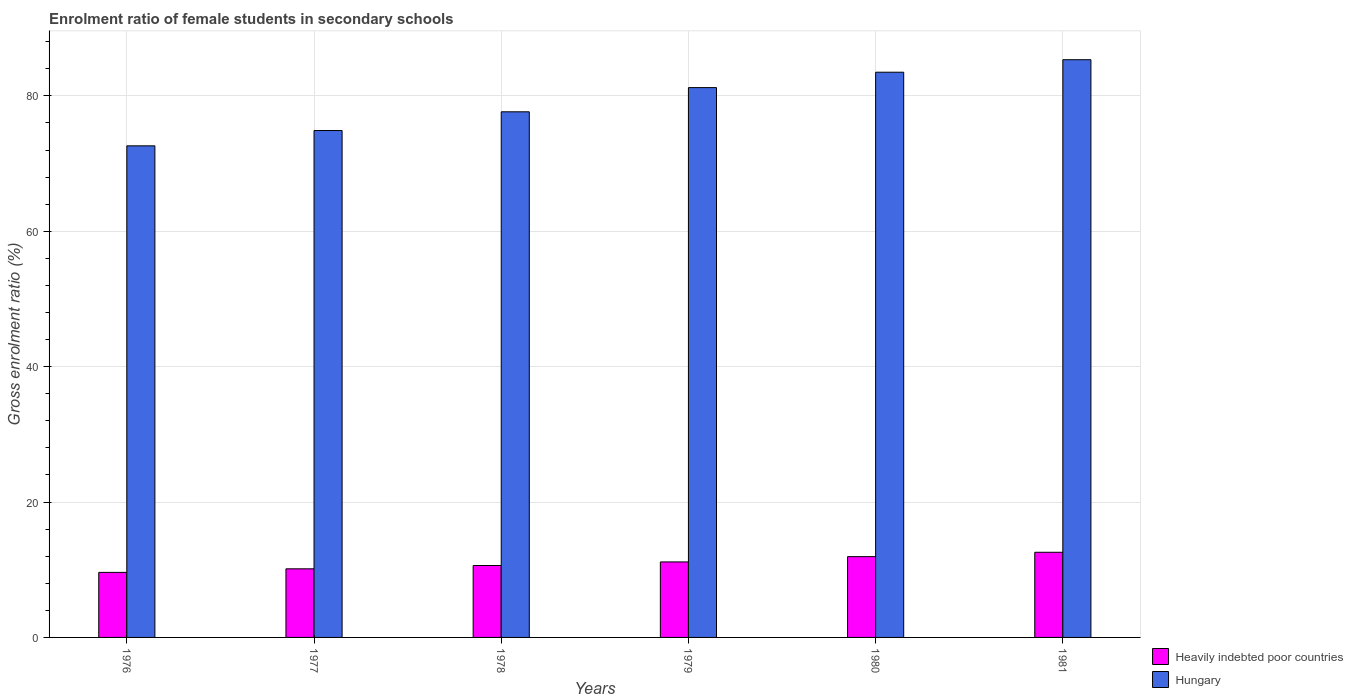How many groups of bars are there?
Provide a succinct answer. 6. Are the number of bars per tick equal to the number of legend labels?
Provide a succinct answer. Yes. How many bars are there on the 4th tick from the left?
Give a very brief answer. 2. What is the label of the 2nd group of bars from the left?
Your answer should be very brief. 1977. In how many cases, is the number of bars for a given year not equal to the number of legend labels?
Your answer should be compact. 0. What is the enrolment ratio of female students in secondary schools in Hungary in 1980?
Your answer should be very brief. 83.49. Across all years, what is the maximum enrolment ratio of female students in secondary schools in Heavily indebted poor countries?
Your answer should be compact. 12.58. Across all years, what is the minimum enrolment ratio of female students in secondary schools in Hungary?
Provide a short and direct response. 72.61. In which year was the enrolment ratio of female students in secondary schools in Hungary minimum?
Provide a succinct answer. 1976. What is the total enrolment ratio of female students in secondary schools in Hungary in the graph?
Your answer should be very brief. 475.18. What is the difference between the enrolment ratio of female students in secondary schools in Heavily indebted poor countries in 1976 and that in 1977?
Your answer should be very brief. -0.53. What is the difference between the enrolment ratio of female students in secondary schools in Hungary in 1981 and the enrolment ratio of female students in secondary schools in Heavily indebted poor countries in 1978?
Provide a short and direct response. 74.71. What is the average enrolment ratio of female students in secondary schools in Hungary per year?
Offer a very short reply. 79.2. In the year 1979, what is the difference between the enrolment ratio of female students in secondary schools in Hungary and enrolment ratio of female students in secondary schools in Heavily indebted poor countries?
Your response must be concise. 70.06. What is the ratio of the enrolment ratio of female students in secondary schools in Hungary in 1979 to that in 1981?
Provide a succinct answer. 0.95. Is the enrolment ratio of female students in secondary schools in Heavily indebted poor countries in 1977 less than that in 1981?
Keep it short and to the point. Yes. Is the difference between the enrolment ratio of female students in secondary schools in Hungary in 1977 and 1980 greater than the difference between the enrolment ratio of female students in secondary schools in Heavily indebted poor countries in 1977 and 1980?
Give a very brief answer. No. What is the difference between the highest and the second highest enrolment ratio of female students in secondary schools in Heavily indebted poor countries?
Offer a very short reply. 0.64. What is the difference between the highest and the lowest enrolment ratio of female students in secondary schools in Heavily indebted poor countries?
Ensure brevity in your answer.  2.97. Is the sum of the enrolment ratio of female students in secondary schools in Hungary in 1980 and 1981 greater than the maximum enrolment ratio of female students in secondary schools in Heavily indebted poor countries across all years?
Provide a succinct answer. Yes. What does the 1st bar from the left in 1981 represents?
Give a very brief answer. Heavily indebted poor countries. What does the 2nd bar from the right in 1979 represents?
Your response must be concise. Heavily indebted poor countries. Does the graph contain grids?
Make the answer very short. Yes. Where does the legend appear in the graph?
Your answer should be compact. Bottom right. How many legend labels are there?
Ensure brevity in your answer.  2. What is the title of the graph?
Give a very brief answer. Enrolment ratio of female students in secondary schools. Does "Middle East & North Africa (all income levels)" appear as one of the legend labels in the graph?
Provide a short and direct response. No. What is the label or title of the Y-axis?
Your answer should be very brief. Gross enrolment ratio (%). What is the Gross enrolment ratio (%) of Heavily indebted poor countries in 1976?
Your response must be concise. 9.61. What is the Gross enrolment ratio (%) in Hungary in 1976?
Provide a succinct answer. 72.61. What is the Gross enrolment ratio (%) of Heavily indebted poor countries in 1977?
Offer a very short reply. 10.13. What is the Gross enrolment ratio (%) of Hungary in 1977?
Provide a short and direct response. 74.88. What is the Gross enrolment ratio (%) of Heavily indebted poor countries in 1978?
Ensure brevity in your answer.  10.62. What is the Gross enrolment ratio (%) in Hungary in 1978?
Provide a short and direct response. 77.64. What is the Gross enrolment ratio (%) in Heavily indebted poor countries in 1979?
Your response must be concise. 11.15. What is the Gross enrolment ratio (%) in Hungary in 1979?
Offer a terse response. 81.22. What is the Gross enrolment ratio (%) in Heavily indebted poor countries in 1980?
Offer a very short reply. 11.93. What is the Gross enrolment ratio (%) in Hungary in 1980?
Your answer should be compact. 83.49. What is the Gross enrolment ratio (%) of Heavily indebted poor countries in 1981?
Provide a succinct answer. 12.58. What is the Gross enrolment ratio (%) in Hungary in 1981?
Provide a succinct answer. 85.34. Across all years, what is the maximum Gross enrolment ratio (%) of Heavily indebted poor countries?
Offer a terse response. 12.58. Across all years, what is the maximum Gross enrolment ratio (%) in Hungary?
Offer a terse response. 85.34. Across all years, what is the minimum Gross enrolment ratio (%) in Heavily indebted poor countries?
Your answer should be very brief. 9.61. Across all years, what is the minimum Gross enrolment ratio (%) of Hungary?
Make the answer very short. 72.61. What is the total Gross enrolment ratio (%) in Heavily indebted poor countries in the graph?
Offer a very short reply. 66.03. What is the total Gross enrolment ratio (%) of Hungary in the graph?
Your response must be concise. 475.18. What is the difference between the Gross enrolment ratio (%) of Heavily indebted poor countries in 1976 and that in 1977?
Provide a short and direct response. -0.53. What is the difference between the Gross enrolment ratio (%) of Hungary in 1976 and that in 1977?
Offer a very short reply. -2.26. What is the difference between the Gross enrolment ratio (%) in Heavily indebted poor countries in 1976 and that in 1978?
Offer a terse response. -1.01. What is the difference between the Gross enrolment ratio (%) of Hungary in 1976 and that in 1978?
Your answer should be very brief. -5.03. What is the difference between the Gross enrolment ratio (%) of Heavily indebted poor countries in 1976 and that in 1979?
Offer a very short reply. -1.54. What is the difference between the Gross enrolment ratio (%) of Hungary in 1976 and that in 1979?
Provide a short and direct response. -8.6. What is the difference between the Gross enrolment ratio (%) of Heavily indebted poor countries in 1976 and that in 1980?
Provide a succinct answer. -2.33. What is the difference between the Gross enrolment ratio (%) in Hungary in 1976 and that in 1980?
Offer a very short reply. -10.88. What is the difference between the Gross enrolment ratio (%) in Heavily indebted poor countries in 1976 and that in 1981?
Keep it short and to the point. -2.97. What is the difference between the Gross enrolment ratio (%) of Hungary in 1976 and that in 1981?
Your answer should be very brief. -12.72. What is the difference between the Gross enrolment ratio (%) in Heavily indebted poor countries in 1977 and that in 1978?
Keep it short and to the point. -0.49. What is the difference between the Gross enrolment ratio (%) in Hungary in 1977 and that in 1978?
Give a very brief answer. -2.76. What is the difference between the Gross enrolment ratio (%) in Heavily indebted poor countries in 1977 and that in 1979?
Provide a short and direct response. -1.02. What is the difference between the Gross enrolment ratio (%) of Hungary in 1977 and that in 1979?
Your answer should be very brief. -6.34. What is the difference between the Gross enrolment ratio (%) of Heavily indebted poor countries in 1977 and that in 1980?
Make the answer very short. -1.8. What is the difference between the Gross enrolment ratio (%) in Hungary in 1977 and that in 1980?
Offer a very short reply. -8.61. What is the difference between the Gross enrolment ratio (%) of Heavily indebted poor countries in 1977 and that in 1981?
Your answer should be very brief. -2.44. What is the difference between the Gross enrolment ratio (%) of Hungary in 1977 and that in 1981?
Give a very brief answer. -10.46. What is the difference between the Gross enrolment ratio (%) in Heavily indebted poor countries in 1978 and that in 1979?
Provide a succinct answer. -0.53. What is the difference between the Gross enrolment ratio (%) of Hungary in 1978 and that in 1979?
Give a very brief answer. -3.57. What is the difference between the Gross enrolment ratio (%) of Heavily indebted poor countries in 1978 and that in 1980?
Keep it short and to the point. -1.31. What is the difference between the Gross enrolment ratio (%) of Hungary in 1978 and that in 1980?
Make the answer very short. -5.85. What is the difference between the Gross enrolment ratio (%) of Heavily indebted poor countries in 1978 and that in 1981?
Your answer should be very brief. -1.95. What is the difference between the Gross enrolment ratio (%) in Hungary in 1978 and that in 1981?
Provide a succinct answer. -7.7. What is the difference between the Gross enrolment ratio (%) in Heavily indebted poor countries in 1979 and that in 1980?
Provide a short and direct response. -0.78. What is the difference between the Gross enrolment ratio (%) of Hungary in 1979 and that in 1980?
Your answer should be very brief. -2.27. What is the difference between the Gross enrolment ratio (%) in Heavily indebted poor countries in 1979 and that in 1981?
Offer a very short reply. -1.42. What is the difference between the Gross enrolment ratio (%) in Hungary in 1979 and that in 1981?
Offer a very short reply. -4.12. What is the difference between the Gross enrolment ratio (%) in Heavily indebted poor countries in 1980 and that in 1981?
Your answer should be compact. -0.64. What is the difference between the Gross enrolment ratio (%) in Hungary in 1980 and that in 1981?
Offer a terse response. -1.85. What is the difference between the Gross enrolment ratio (%) of Heavily indebted poor countries in 1976 and the Gross enrolment ratio (%) of Hungary in 1977?
Offer a very short reply. -65.27. What is the difference between the Gross enrolment ratio (%) in Heavily indebted poor countries in 1976 and the Gross enrolment ratio (%) in Hungary in 1978?
Provide a short and direct response. -68.03. What is the difference between the Gross enrolment ratio (%) of Heavily indebted poor countries in 1976 and the Gross enrolment ratio (%) of Hungary in 1979?
Offer a terse response. -71.61. What is the difference between the Gross enrolment ratio (%) of Heavily indebted poor countries in 1976 and the Gross enrolment ratio (%) of Hungary in 1980?
Offer a very short reply. -73.88. What is the difference between the Gross enrolment ratio (%) of Heavily indebted poor countries in 1976 and the Gross enrolment ratio (%) of Hungary in 1981?
Your answer should be compact. -75.73. What is the difference between the Gross enrolment ratio (%) in Heavily indebted poor countries in 1977 and the Gross enrolment ratio (%) in Hungary in 1978?
Your answer should be compact. -67.51. What is the difference between the Gross enrolment ratio (%) in Heavily indebted poor countries in 1977 and the Gross enrolment ratio (%) in Hungary in 1979?
Give a very brief answer. -71.08. What is the difference between the Gross enrolment ratio (%) of Heavily indebted poor countries in 1977 and the Gross enrolment ratio (%) of Hungary in 1980?
Offer a very short reply. -73.36. What is the difference between the Gross enrolment ratio (%) in Heavily indebted poor countries in 1977 and the Gross enrolment ratio (%) in Hungary in 1981?
Give a very brief answer. -75.2. What is the difference between the Gross enrolment ratio (%) of Heavily indebted poor countries in 1978 and the Gross enrolment ratio (%) of Hungary in 1979?
Keep it short and to the point. -70.59. What is the difference between the Gross enrolment ratio (%) in Heavily indebted poor countries in 1978 and the Gross enrolment ratio (%) in Hungary in 1980?
Your response must be concise. -72.87. What is the difference between the Gross enrolment ratio (%) of Heavily indebted poor countries in 1978 and the Gross enrolment ratio (%) of Hungary in 1981?
Offer a terse response. -74.71. What is the difference between the Gross enrolment ratio (%) in Heavily indebted poor countries in 1979 and the Gross enrolment ratio (%) in Hungary in 1980?
Keep it short and to the point. -72.34. What is the difference between the Gross enrolment ratio (%) of Heavily indebted poor countries in 1979 and the Gross enrolment ratio (%) of Hungary in 1981?
Keep it short and to the point. -74.18. What is the difference between the Gross enrolment ratio (%) of Heavily indebted poor countries in 1980 and the Gross enrolment ratio (%) of Hungary in 1981?
Your response must be concise. -73.4. What is the average Gross enrolment ratio (%) of Heavily indebted poor countries per year?
Your answer should be very brief. 11.01. What is the average Gross enrolment ratio (%) of Hungary per year?
Make the answer very short. 79.2. In the year 1976, what is the difference between the Gross enrolment ratio (%) of Heavily indebted poor countries and Gross enrolment ratio (%) of Hungary?
Make the answer very short. -63.01. In the year 1977, what is the difference between the Gross enrolment ratio (%) of Heavily indebted poor countries and Gross enrolment ratio (%) of Hungary?
Provide a short and direct response. -64.74. In the year 1978, what is the difference between the Gross enrolment ratio (%) in Heavily indebted poor countries and Gross enrolment ratio (%) in Hungary?
Keep it short and to the point. -67.02. In the year 1979, what is the difference between the Gross enrolment ratio (%) of Heavily indebted poor countries and Gross enrolment ratio (%) of Hungary?
Give a very brief answer. -70.06. In the year 1980, what is the difference between the Gross enrolment ratio (%) of Heavily indebted poor countries and Gross enrolment ratio (%) of Hungary?
Keep it short and to the point. -71.56. In the year 1981, what is the difference between the Gross enrolment ratio (%) in Heavily indebted poor countries and Gross enrolment ratio (%) in Hungary?
Your answer should be very brief. -72.76. What is the ratio of the Gross enrolment ratio (%) in Heavily indebted poor countries in 1976 to that in 1977?
Keep it short and to the point. 0.95. What is the ratio of the Gross enrolment ratio (%) of Hungary in 1976 to that in 1977?
Offer a terse response. 0.97. What is the ratio of the Gross enrolment ratio (%) of Heavily indebted poor countries in 1976 to that in 1978?
Provide a succinct answer. 0.9. What is the ratio of the Gross enrolment ratio (%) in Hungary in 1976 to that in 1978?
Make the answer very short. 0.94. What is the ratio of the Gross enrolment ratio (%) in Heavily indebted poor countries in 1976 to that in 1979?
Your answer should be very brief. 0.86. What is the ratio of the Gross enrolment ratio (%) of Hungary in 1976 to that in 1979?
Provide a succinct answer. 0.89. What is the ratio of the Gross enrolment ratio (%) of Heavily indebted poor countries in 1976 to that in 1980?
Ensure brevity in your answer.  0.81. What is the ratio of the Gross enrolment ratio (%) of Hungary in 1976 to that in 1980?
Provide a succinct answer. 0.87. What is the ratio of the Gross enrolment ratio (%) of Heavily indebted poor countries in 1976 to that in 1981?
Make the answer very short. 0.76. What is the ratio of the Gross enrolment ratio (%) of Hungary in 1976 to that in 1981?
Make the answer very short. 0.85. What is the ratio of the Gross enrolment ratio (%) of Heavily indebted poor countries in 1977 to that in 1978?
Offer a terse response. 0.95. What is the ratio of the Gross enrolment ratio (%) in Hungary in 1977 to that in 1978?
Your answer should be compact. 0.96. What is the ratio of the Gross enrolment ratio (%) in Heavily indebted poor countries in 1977 to that in 1979?
Your answer should be compact. 0.91. What is the ratio of the Gross enrolment ratio (%) of Hungary in 1977 to that in 1979?
Your response must be concise. 0.92. What is the ratio of the Gross enrolment ratio (%) of Heavily indebted poor countries in 1977 to that in 1980?
Keep it short and to the point. 0.85. What is the ratio of the Gross enrolment ratio (%) in Hungary in 1977 to that in 1980?
Offer a terse response. 0.9. What is the ratio of the Gross enrolment ratio (%) of Heavily indebted poor countries in 1977 to that in 1981?
Offer a terse response. 0.81. What is the ratio of the Gross enrolment ratio (%) of Hungary in 1977 to that in 1981?
Provide a short and direct response. 0.88. What is the ratio of the Gross enrolment ratio (%) in Heavily indebted poor countries in 1978 to that in 1979?
Your answer should be compact. 0.95. What is the ratio of the Gross enrolment ratio (%) of Hungary in 1978 to that in 1979?
Offer a very short reply. 0.96. What is the ratio of the Gross enrolment ratio (%) in Heavily indebted poor countries in 1978 to that in 1980?
Make the answer very short. 0.89. What is the ratio of the Gross enrolment ratio (%) of Hungary in 1978 to that in 1980?
Offer a terse response. 0.93. What is the ratio of the Gross enrolment ratio (%) in Heavily indebted poor countries in 1978 to that in 1981?
Offer a very short reply. 0.84. What is the ratio of the Gross enrolment ratio (%) of Hungary in 1978 to that in 1981?
Your answer should be compact. 0.91. What is the ratio of the Gross enrolment ratio (%) in Heavily indebted poor countries in 1979 to that in 1980?
Your answer should be compact. 0.93. What is the ratio of the Gross enrolment ratio (%) of Hungary in 1979 to that in 1980?
Give a very brief answer. 0.97. What is the ratio of the Gross enrolment ratio (%) in Heavily indebted poor countries in 1979 to that in 1981?
Provide a succinct answer. 0.89. What is the ratio of the Gross enrolment ratio (%) in Hungary in 1979 to that in 1981?
Your answer should be very brief. 0.95. What is the ratio of the Gross enrolment ratio (%) in Heavily indebted poor countries in 1980 to that in 1981?
Offer a very short reply. 0.95. What is the ratio of the Gross enrolment ratio (%) in Hungary in 1980 to that in 1981?
Provide a short and direct response. 0.98. What is the difference between the highest and the second highest Gross enrolment ratio (%) in Heavily indebted poor countries?
Ensure brevity in your answer.  0.64. What is the difference between the highest and the second highest Gross enrolment ratio (%) of Hungary?
Keep it short and to the point. 1.85. What is the difference between the highest and the lowest Gross enrolment ratio (%) of Heavily indebted poor countries?
Make the answer very short. 2.97. What is the difference between the highest and the lowest Gross enrolment ratio (%) in Hungary?
Give a very brief answer. 12.72. 